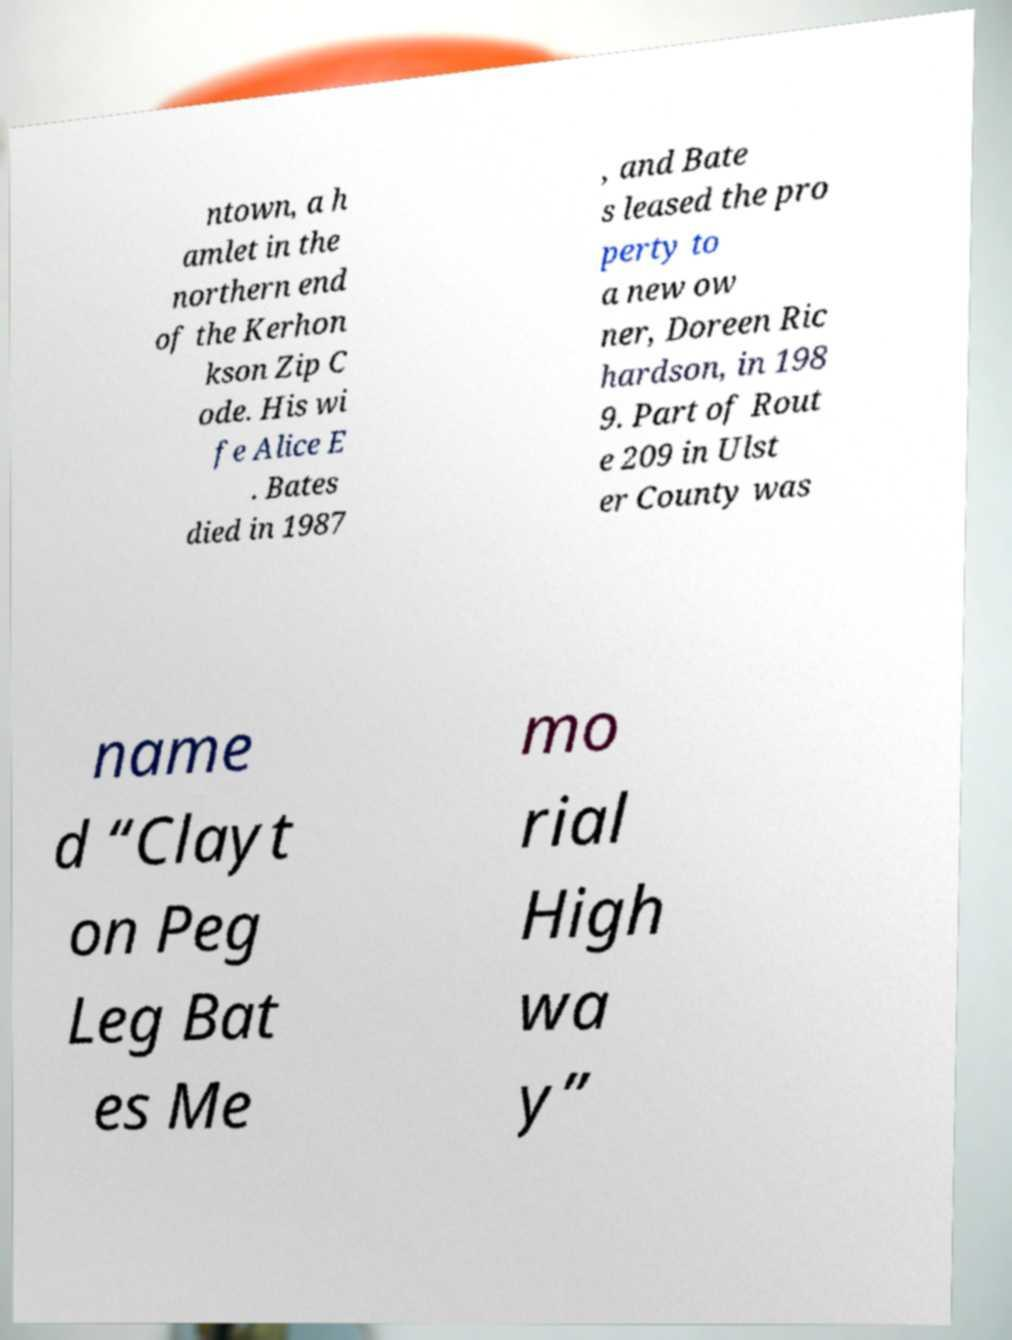I need the written content from this picture converted into text. Can you do that? ntown, a h amlet in the northern end of the Kerhon kson Zip C ode. His wi fe Alice E . Bates died in 1987 , and Bate s leased the pro perty to a new ow ner, Doreen Ric hardson, in 198 9. Part of Rout e 209 in Ulst er County was name d “Clayt on Peg Leg Bat es Me mo rial High wa y” 